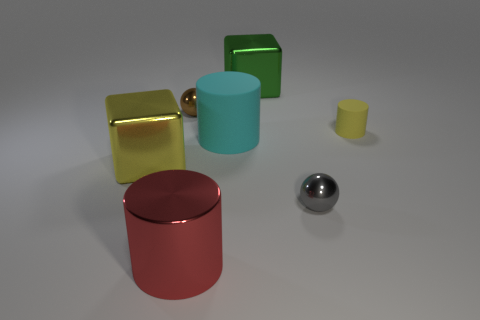What number of things are either small balls to the left of the gray shiny thing or tiny metal objects?
Ensure brevity in your answer.  2. How many objects are either rubber cylinders or metal spheres to the left of the tiny gray object?
Your response must be concise. 3. What number of tiny matte cylinders are on the left side of the big object in front of the large metallic block that is left of the brown shiny ball?
Ensure brevity in your answer.  0. There is a green cube that is the same size as the red cylinder; what material is it?
Give a very brief answer. Metal. Are there any brown balls of the same size as the red metal object?
Your answer should be very brief. No. What color is the large rubber cylinder?
Provide a succinct answer. Cyan. There is a small metal object that is left of the small ball that is in front of the yellow rubber cylinder; what is its color?
Your response must be concise. Brown. What is the shape of the big metallic thing in front of the metal cube left of the rubber cylinder in front of the yellow rubber cylinder?
Offer a very short reply. Cylinder. How many gray things have the same material as the large green cube?
Make the answer very short. 1. There is a big metallic cube behind the tiny brown metallic sphere; what number of matte things are behind it?
Give a very brief answer. 0. 